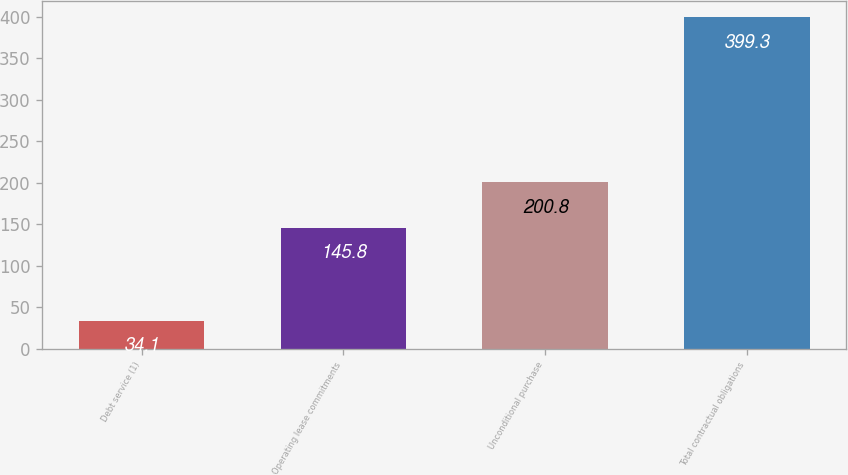Convert chart. <chart><loc_0><loc_0><loc_500><loc_500><bar_chart><fcel>Debt service (1)<fcel>Operating lease commitments<fcel>Unconditional purchase<fcel>Total contractual obligations<nl><fcel>34.1<fcel>145.8<fcel>200.8<fcel>399.3<nl></chart> 